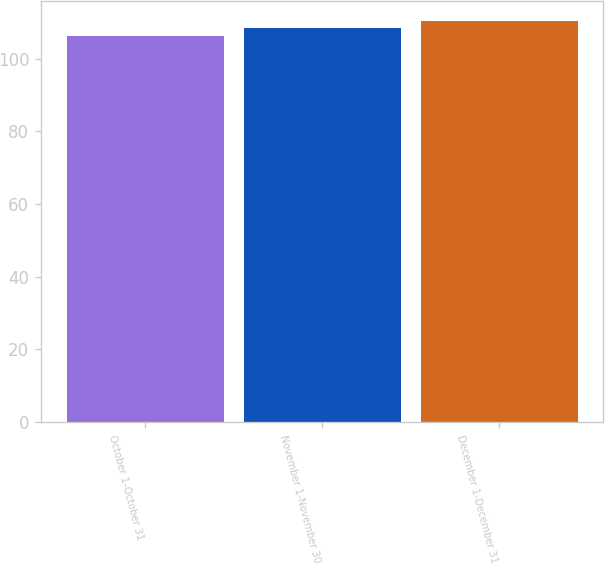Convert chart. <chart><loc_0><loc_0><loc_500><loc_500><bar_chart><fcel>October 1-October 31<fcel>November 1-November 30<fcel>December 1-December 31<nl><fcel>106.17<fcel>108.43<fcel>110.45<nl></chart> 